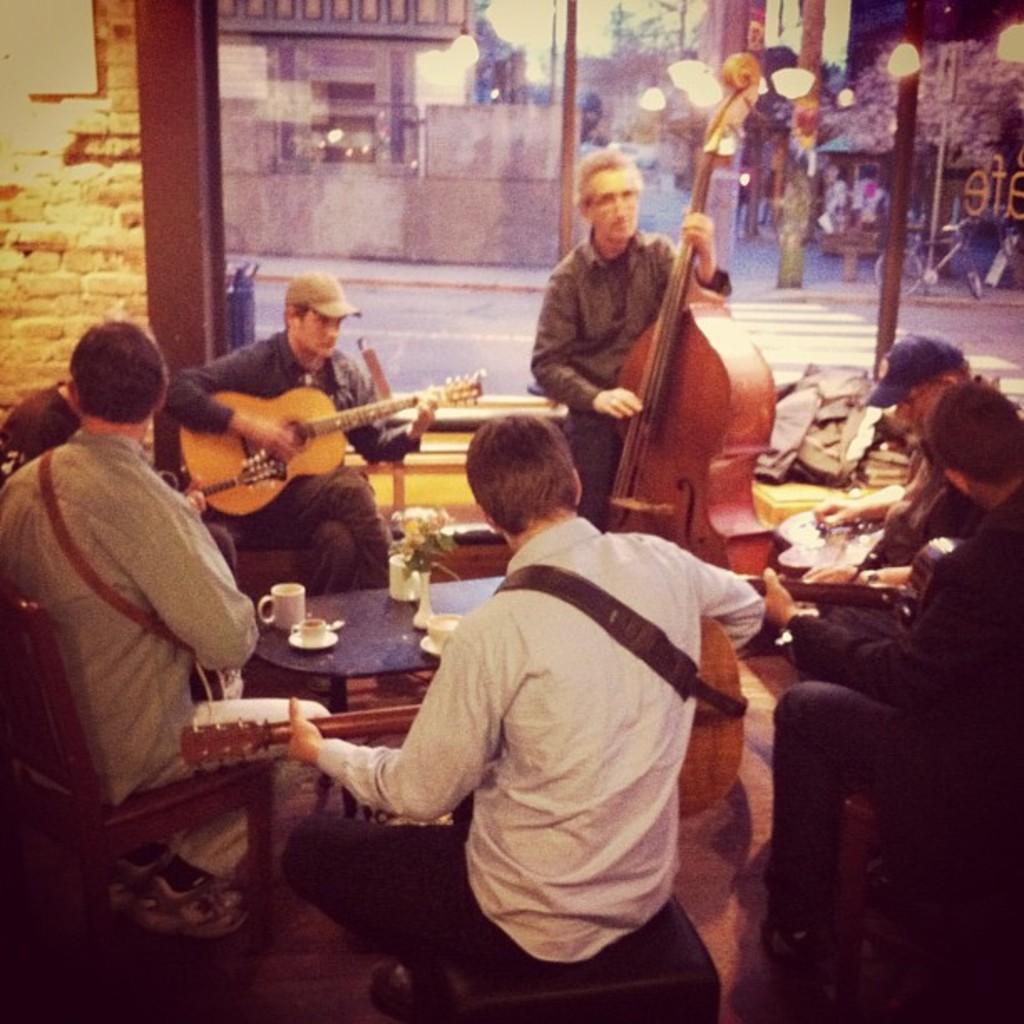How would you summarize this image in a sentence or two? In the picture we can see some people were sitting on the chair around the table,and they were holding the musical instruments. And they were playing and in center the two person were playing the guitar. And on table they were few objects. Coming to the background there is a brick wall and glass. 